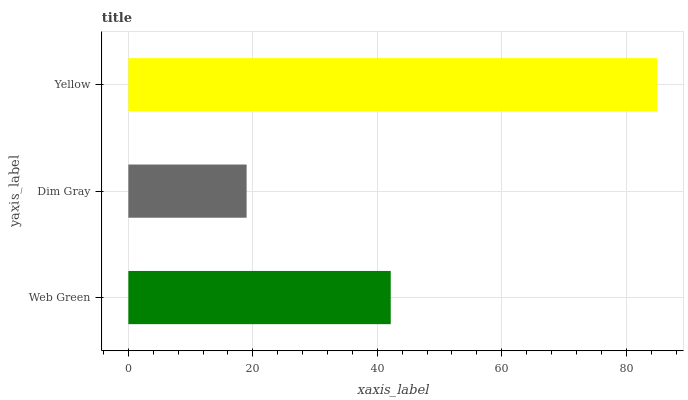Is Dim Gray the minimum?
Answer yes or no. Yes. Is Yellow the maximum?
Answer yes or no. Yes. Is Yellow the minimum?
Answer yes or no. No. Is Dim Gray the maximum?
Answer yes or no. No. Is Yellow greater than Dim Gray?
Answer yes or no. Yes. Is Dim Gray less than Yellow?
Answer yes or no. Yes. Is Dim Gray greater than Yellow?
Answer yes or no. No. Is Yellow less than Dim Gray?
Answer yes or no. No. Is Web Green the high median?
Answer yes or no. Yes. Is Web Green the low median?
Answer yes or no. Yes. Is Yellow the high median?
Answer yes or no. No. Is Dim Gray the low median?
Answer yes or no. No. 